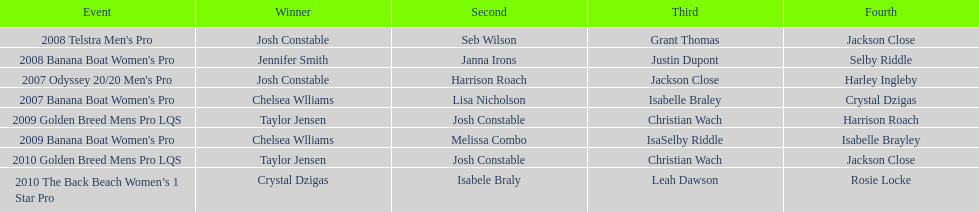Who came in immediately after josh constable in the 2008 telstra men's pro? Seb Wilson. 